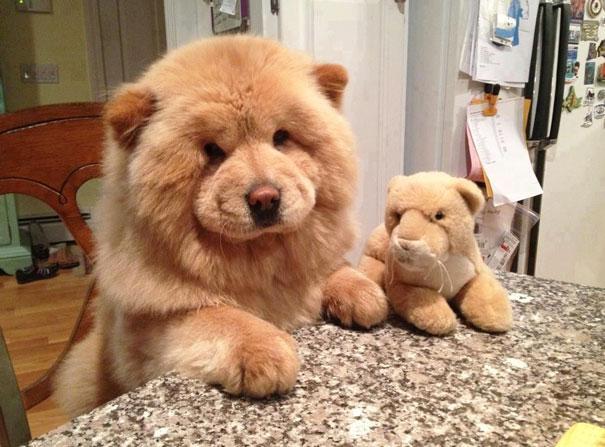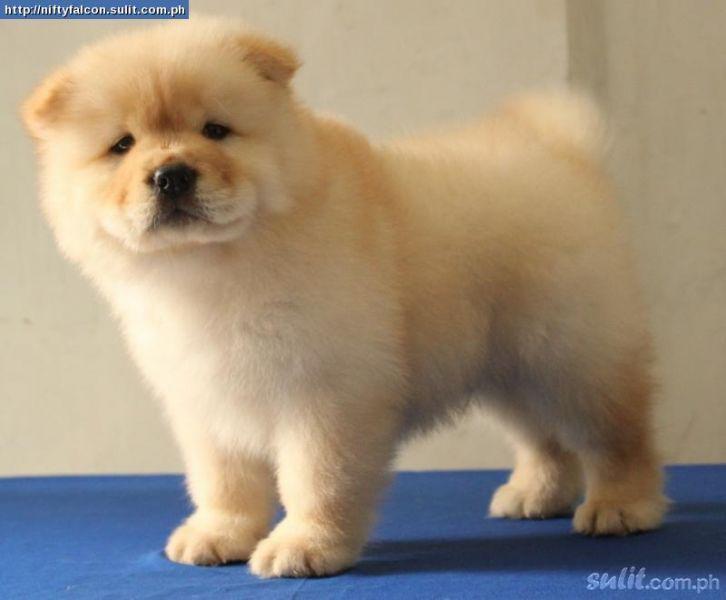The first image is the image on the left, the second image is the image on the right. Examine the images to the left and right. Is the description "There are more living dogs in the image on the left." accurate? Answer yes or no. No. The first image is the image on the left, the second image is the image on the right. Analyze the images presented: Is the assertion "The left image contains at least two chow dogs." valid? Answer yes or no. No. 